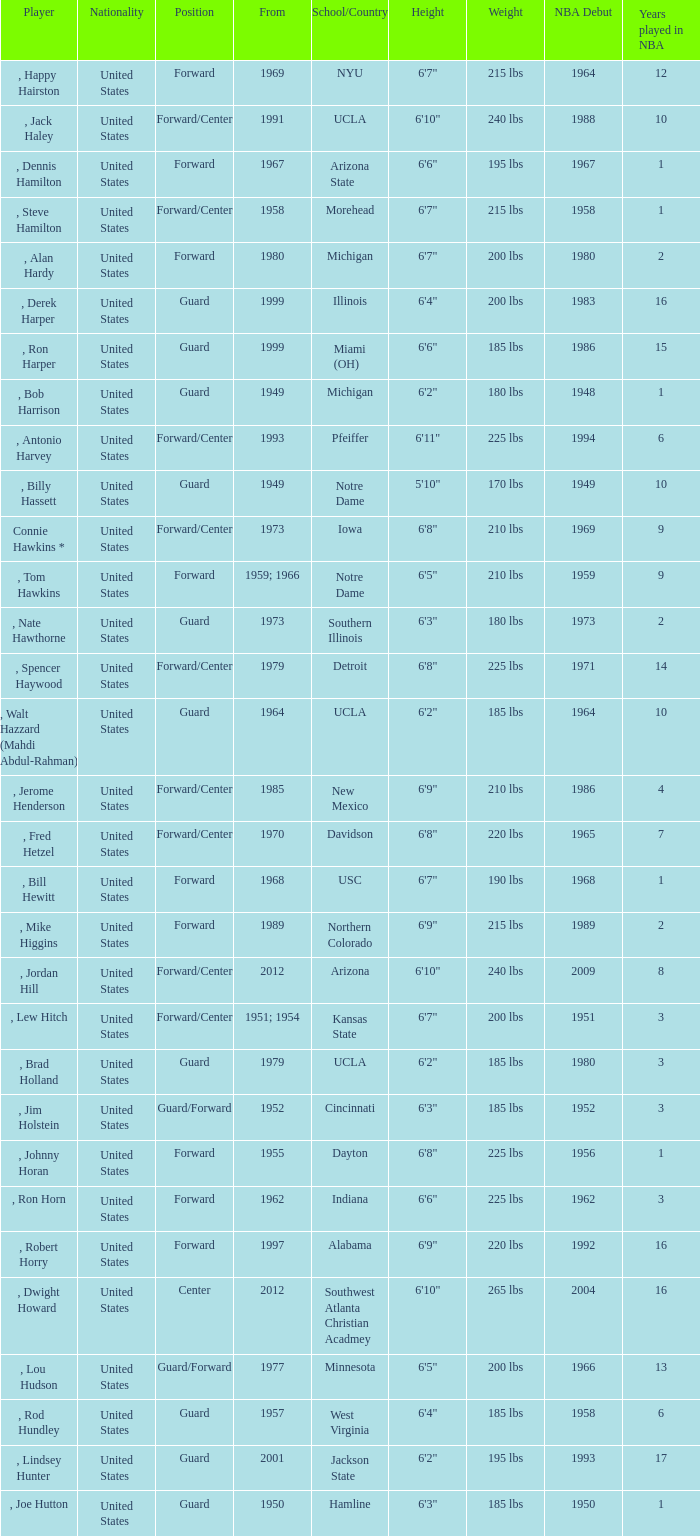Which player started in 2001? , Lindsey Hunter. 